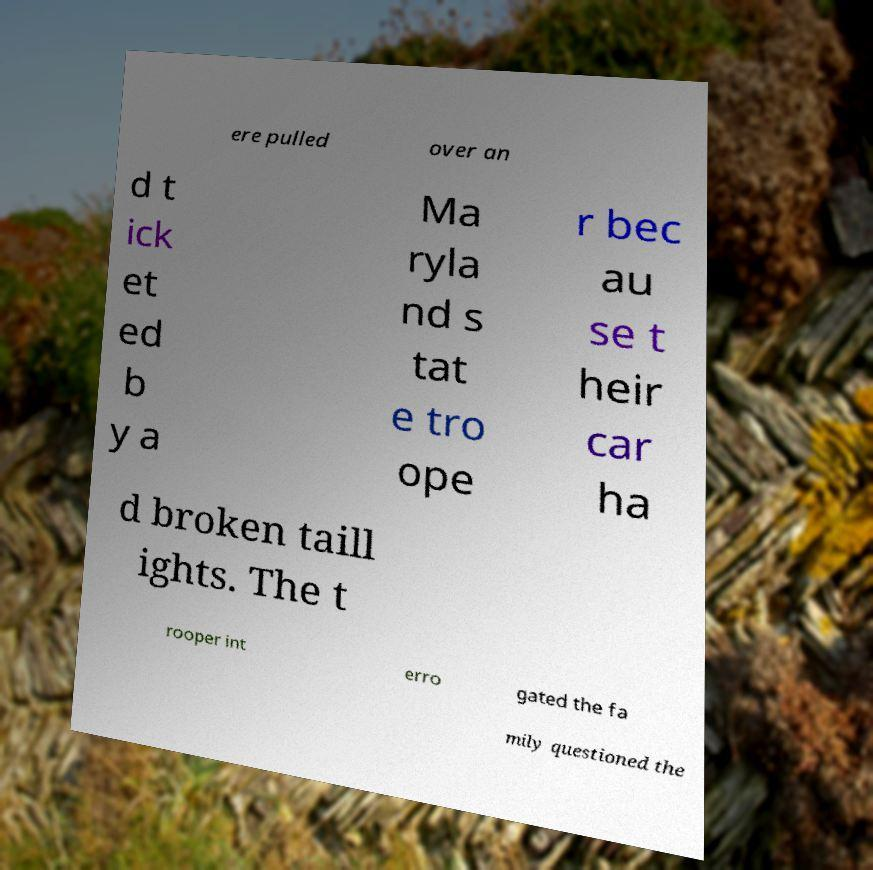Can you read and provide the text displayed in the image?This photo seems to have some interesting text. Can you extract and type it out for me? ere pulled over an d t ick et ed b y a Ma ryla nd s tat e tro ope r bec au se t heir car ha d broken taill ights. The t rooper int erro gated the fa mily questioned the 